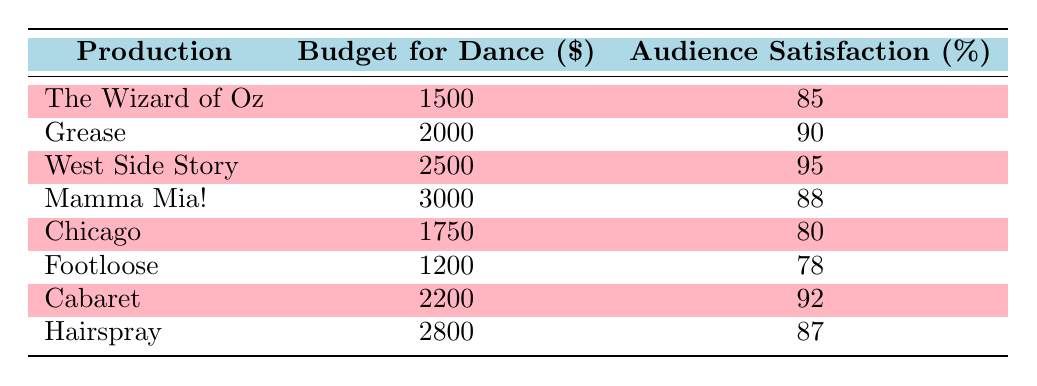What is the budget for dance in "Chicago"? The table lists "Chicago" with a budget for dance, which is located in the respective row, to find it we simply read from the "Budget for Dance" column. The budget is 1750.
Answer: 1750 What is the audience satisfaction percentage for "West Side Story"? To find the audience satisfaction for "West Side Story," we look at its row in the "Audience Satisfaction" column. The value there is 95.
Answer: 95 Which production has the highest audience satisfaction? The highest audience satisfaction is identified by comparing all percentages listed in the "Audience Satisfaction" column. "West Side Story" has the highest figure of 95.
Answer: West Side Story What is the average budget for dance across all productions? To calculate the average budget: (1500 + 2000 + 2500 + 3000 + 1750 + 1200 + 2200 + 2800) = 17950. Since there are 8 productions, we divide by 8: 17950 / 8 = 2231.25.
Answer: 2231.25 Is there a production that has an audience satisfaction score below 80? Looking through the "Audience Satisfaction" column, we check if any production scores below 80. "Footloose" has a score of 78, confirming the existence of a production that meets this criterion.
Answer: Yes What is the difference in audience satisfaction between "Cabaret" and "Mamma Mia!"? To find the difference, we compare the two scores from their respective rows in the "Audience Satisfaction" column: "Cabaret" has 92 and "Mamma Mia!" has 88. The difference is 92 - 88 = 4.
Answer: 4 What is the total budget allocated for dance numbers in "The Wizard of Oz", "Footloose", and "Chicago"? We sum the budgets allocated for these three productions: 1500 (The Wizard of Oz) + 1200 (Footloose) + 1750 (Chicago) = 3950.
Answer: 3950 Do all productions have an audience satisfaction score of 85 or above? By reviewing the "Audience Satisfaction" column, we see "Footloose" has a score of 78, which is below 85, indicating that not all productions meet the criteria.
Answer: No What is the production with the lowest budget for dance numbers? To identify this, we compare the budgets across all productions in the "Budget for Dance" column. "Footloose" has the lowest budget of 1200.
Answer: Footloose What is the percentage increase in audience satisfaction from "Footloose" to "Hairspray"? We calculate the increase: Hairspray (87) - Footloose (78) = 9. Next, we determine the percentage: (9 / 78) * 100 ≈ 11.54%.
Answer: Approximately 11.54% 